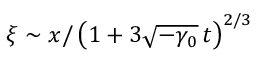Convert formula to latex. <formula><loc_0><loc_0><loc_500><loc_500>\xi \sim x / \left ( 1 + 3 \sqrt { - \gamma _ { 0 } } \, t \right ) ^ { 2 / 3 }</formula> 